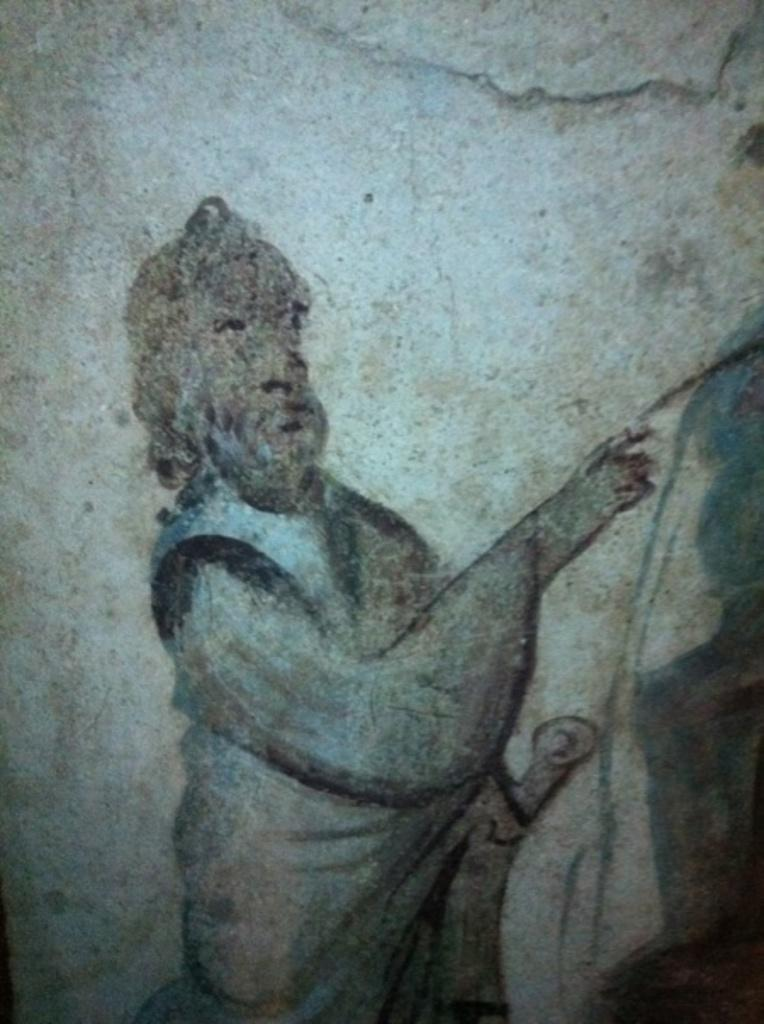What is the main subject of the image? There is a painting in the image. What is the painting depicting? The painting depicts a man raising his hand. Where is the apple located in the painting? There is no apple present in the painting; it depicts a man raising his hand. What type of sail can be seen in the painting? There is no sail present in the painting; it depicts a man raising his hand. 